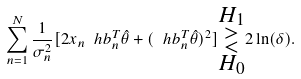<formula> <loc_0><loc_0><loc_500><loc_500>\sum _ { n = 1 } ^ { N } \frac { 1 } { \sigma ^ { 2 } _ { n } } [ 2 x _ { n } \ h b ^ { T } _ { n } \hat { \theta } + ( \ h b ^ { T } _ { n } \hat { \theta } ) ^ { 2 } ] \substack { H _ { 1 } \\ > \\ < \\ H _ { 0 } } 2 \ln ( \delta ) .</formula> 